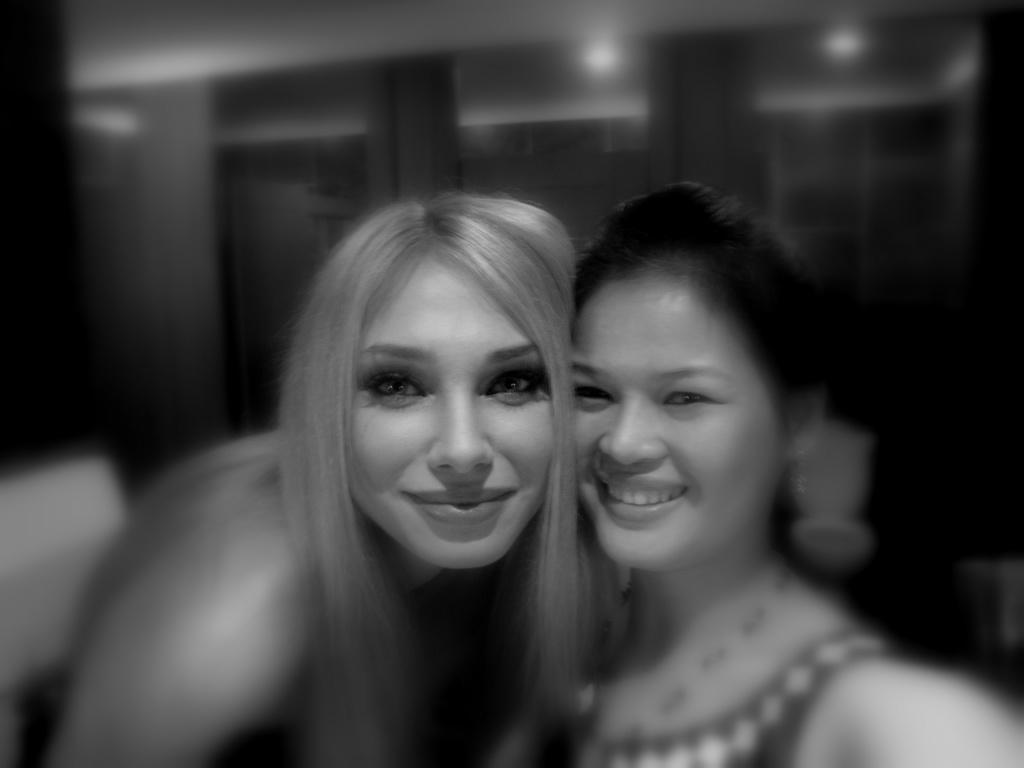Can you describe this image briefly? This is a black and white image. In this image we can see two girls are smiling and attached to each other. The background is blurry. 